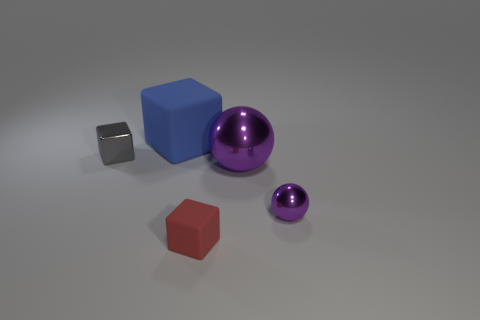Is the number of tiny cubes behind the tiny matte block the same as the number of purple spheres in front of the tiny purple thing?
Your answer should be compact. No. Is the number of small purple spheres that are on the right side of the gray object greater than the number of purple blocks?
Ensure brevity in your answer.  Yes. What number of things are things that are in front of the blue matte cube or big purple metal objects?
Make the answer very short. 4. What number of big objects are made of the same material as the red cube?
Ensure brevity in your answer.  1. Are there any purple metal things of the same shape as the red thing?
Ensure brevity in your answer.  No. There is a matte object that is the same size as the gray metal block; what is its shape?
Make the answer very short. Cube. There is a shiny block; is its color the same as the tiny metal thing that is to the right of the large blue matte object?
Give a very brief answer. No. There is a small object that is in front of the small purple ball; what number of tiny shiny blocks are right of it?
Ensure brevity in your answer.  0. There is a cube that is in front of the big matte block and behind the tiny purple sphere; what size is it?
Provide a succinct answer. Small. Are there any gray shiny things of the same size as the gray cube?
Provide a succinct answer. No. 